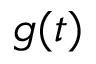<formula> <loc_0><loc_0><loc_500><loc_500>g ( t )</formula> 